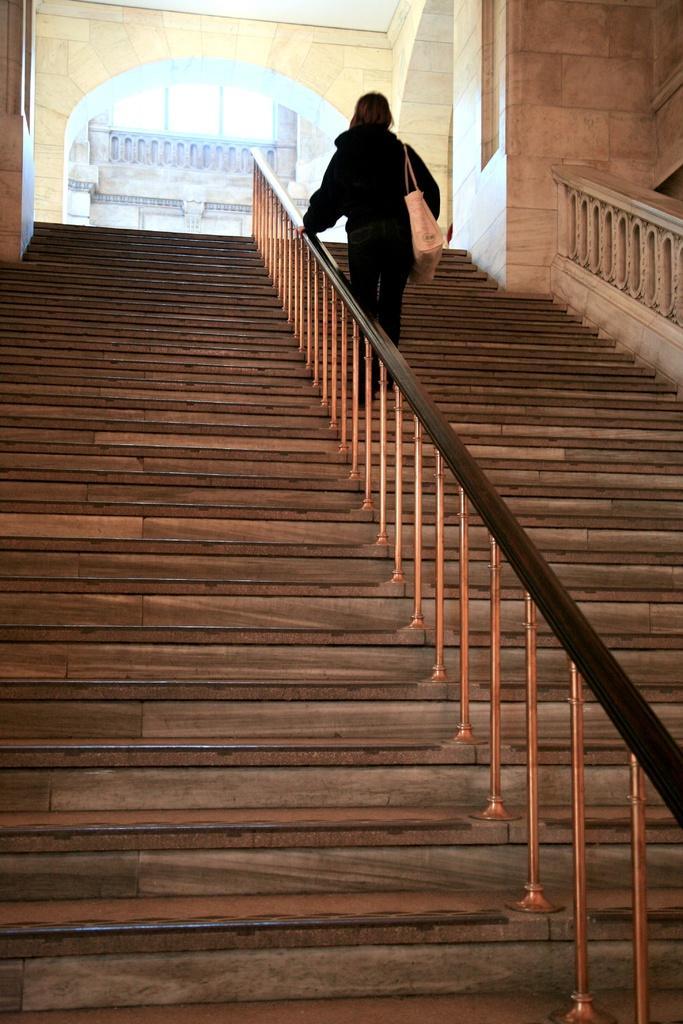How would you summarize this image in a sentence or two? At the top of this image, there is a woman in a black color dress, wearing a handbag, placing a hand on a fence and on the steps of a building. In the background, there is another fence, there is an arch and there is a wall. 